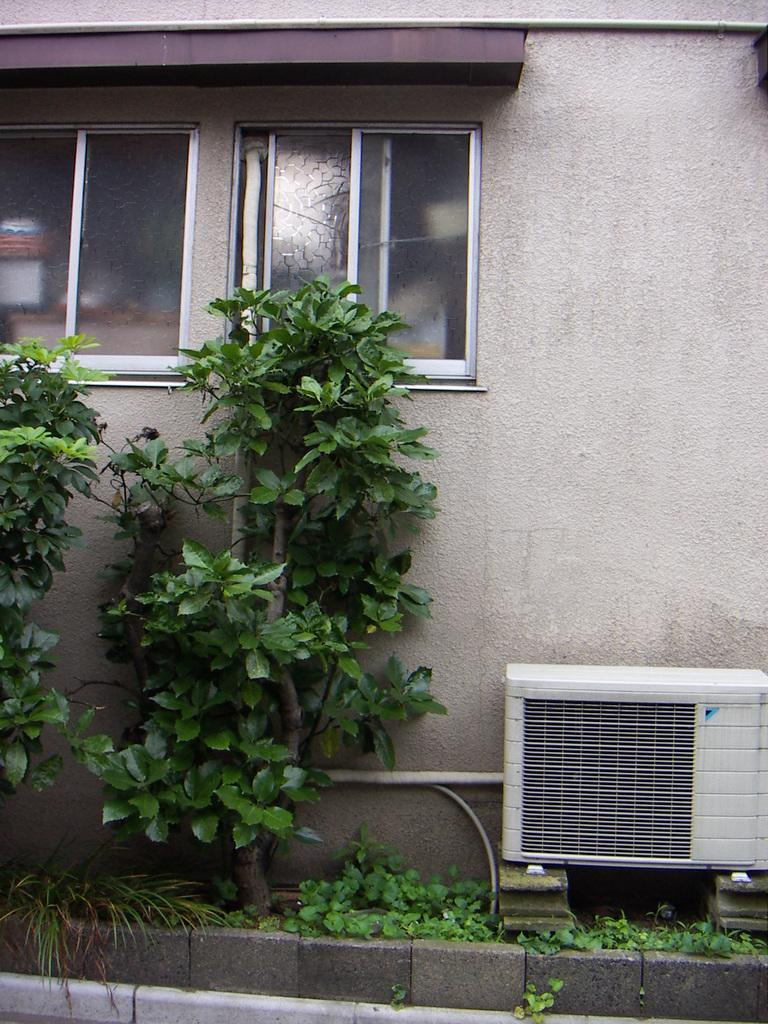What type of living organisms can be seen in the image? Plants can be seen in the image. What is visible in the background of the image? There is a wall in the background of the image. Can you describe the wall in the image? The wall has windows in it. What device is visible in the image? There is an AC visible in the image. Can you describe the sister's tent in the image? There is no sister or tent present in the image. 